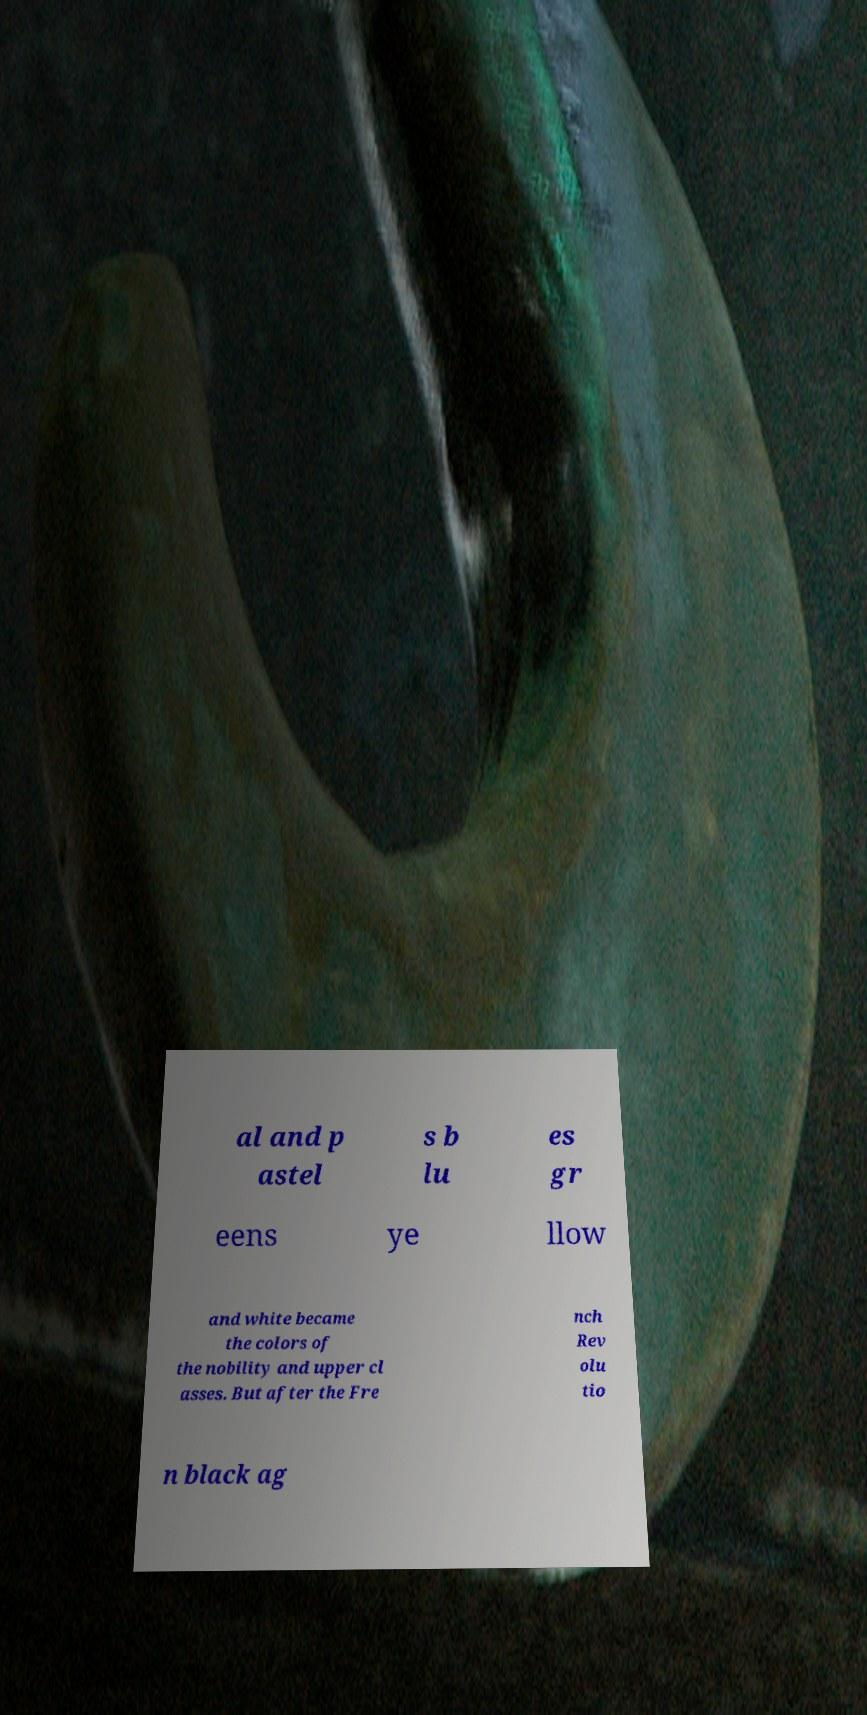Can you read and provide the text displayed in the image?This photo seems to have some interesting text. Can you extract and type it out for me? al and p astel s b lu es gr eens ye llow and white became the colors of the nobility and upper cl asses. But after the Fre nch Rev olu tio n black ag 